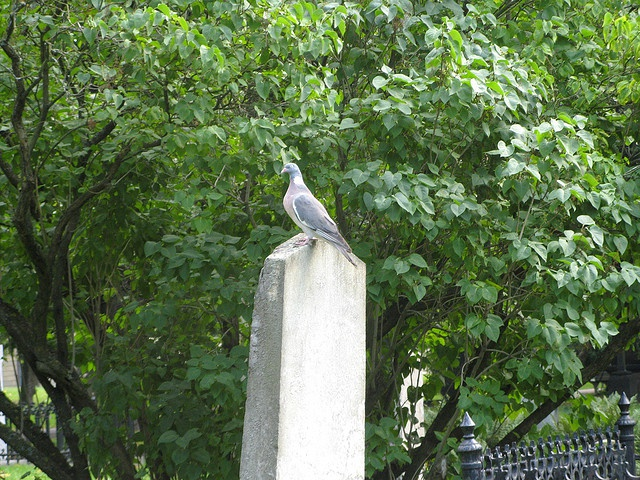Describe the objects in this image and their specific colors. I can see a bird in green, darkgray, lightgray, and gray tones in this image. 